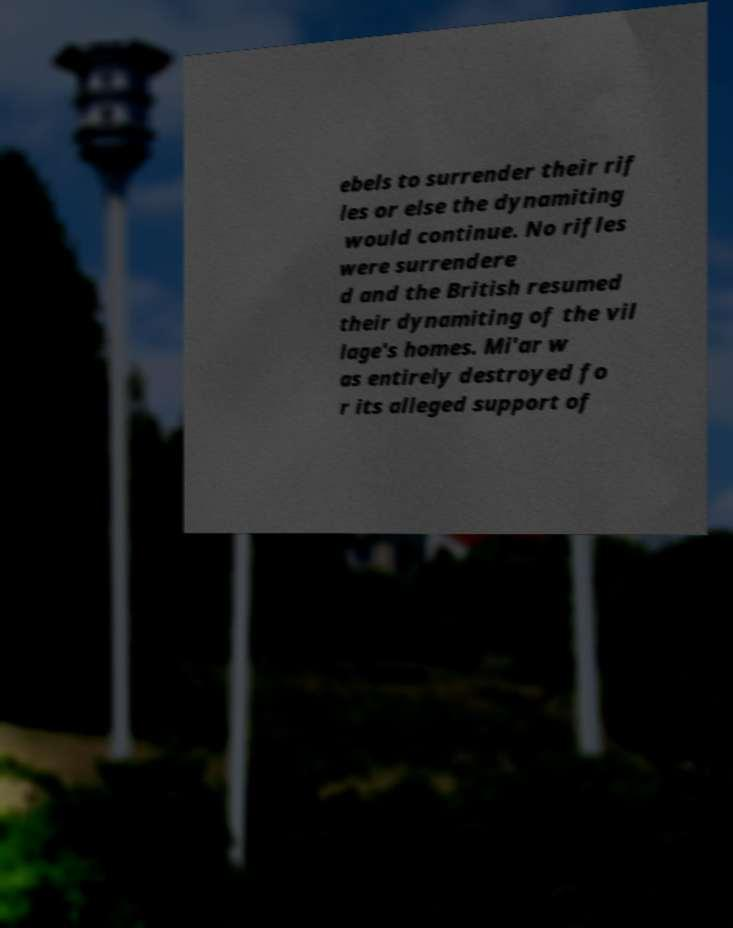Can you read and provide the text displayed in the image?This photo seems to have some interesting text. Can you extract and type it out for me? ebels to surrender their rif les or else the dynamiting would continue. No rifles were surrendere d and the British resumed their dynamiting of the vil lage's homes. Mi'ar w as entirely destroyed fo r its alleged support of 